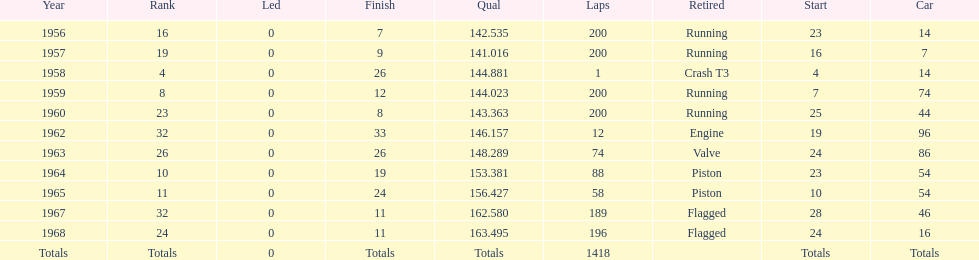How long did bob veith have the number 54 car at the indy 500? 2 years. 